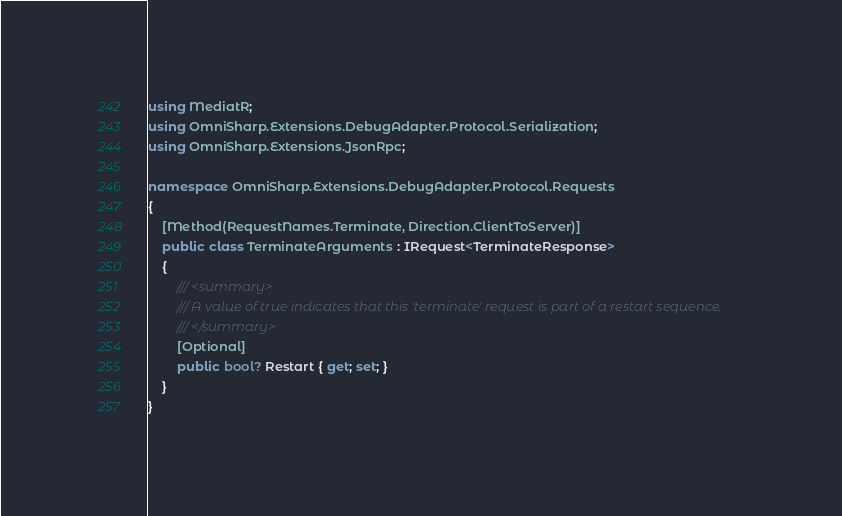Convert code to text. <code><loc_0><loc_0><loc_500><loc_500><_C#_>using MediatR;
using OmniSharp.Extensions.DebugAdapter.Protocol.Serialization;
using OmniSharp.Extensions.JsonRpc;

namespace OmniSharp.Extensions.DebugAdapter.Protocol.Requests
{
    [Method(RequestNames.Terminate, Direction.ClientToServer)]
    public class TerminateArguments : IRequest<TerminateResponse>
    {
        /// <summary>
        /// A value of true indicates that this 'terminate' request is part of a restart sequence.
        /// </summary>
        [Optional]
        public bool? Restart { get; set; }
    }
}
</code> 